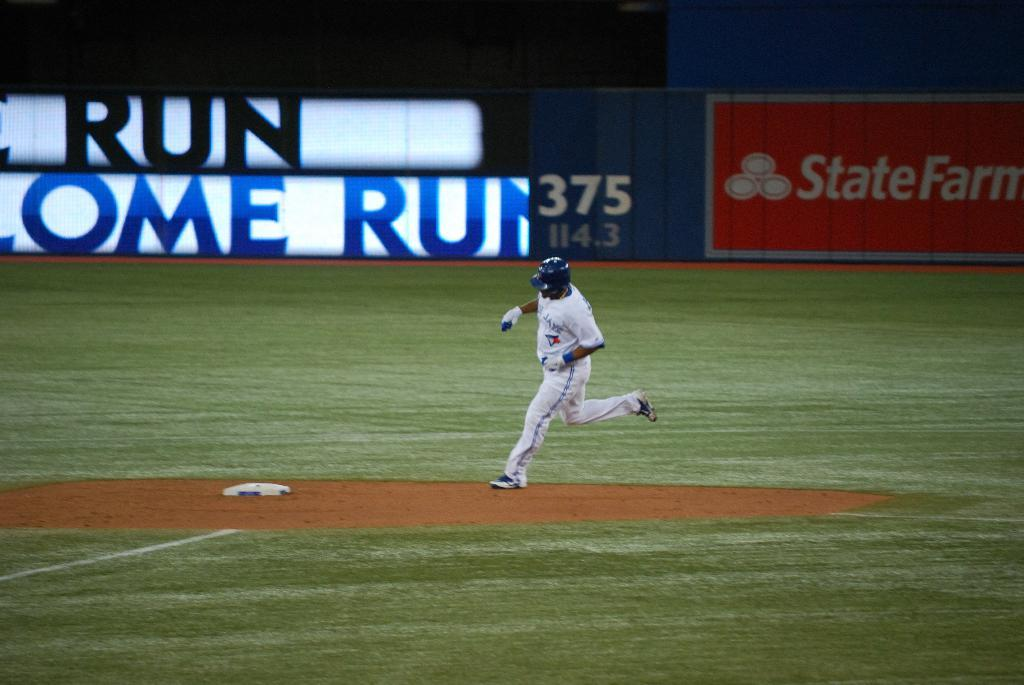<image>
Summarize the visual content of the image. A base ball player runs to a plate with the words home run on a banner 